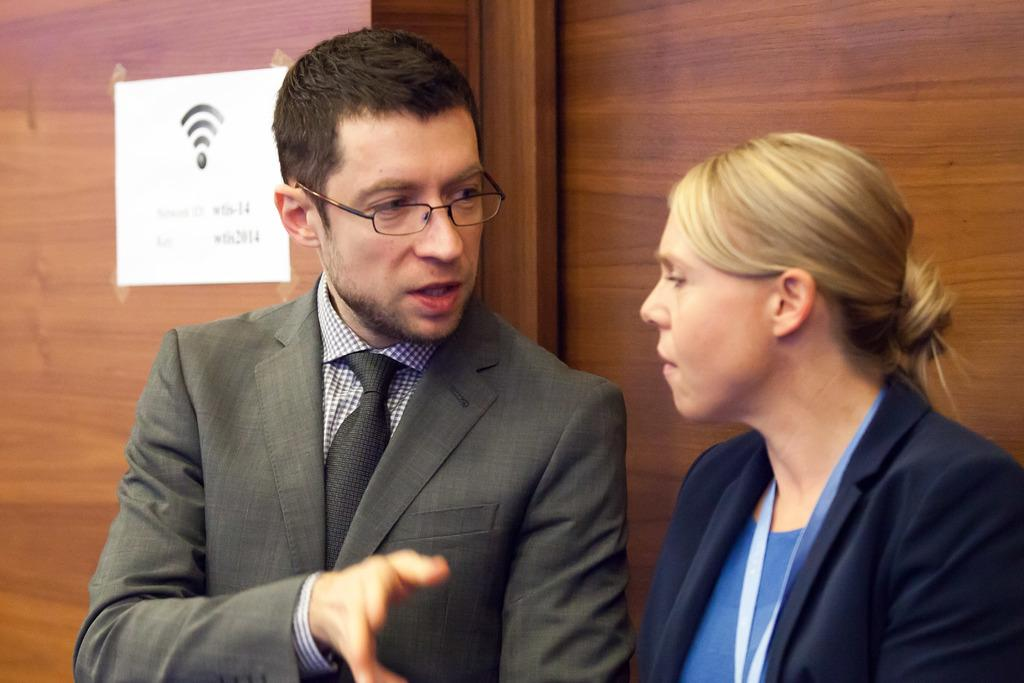How many people are in the image? There are two people standing in the image. What can be observed about their clothing? The people are wearing different colors. What is the color of the wall in the background? There is a brown wall in the background of the image. What is attached to the wall? There is a white paper on the wall. Are the people in the image crying or discussing their education? There is no indication in the image that the people are crying or discussing their education. 